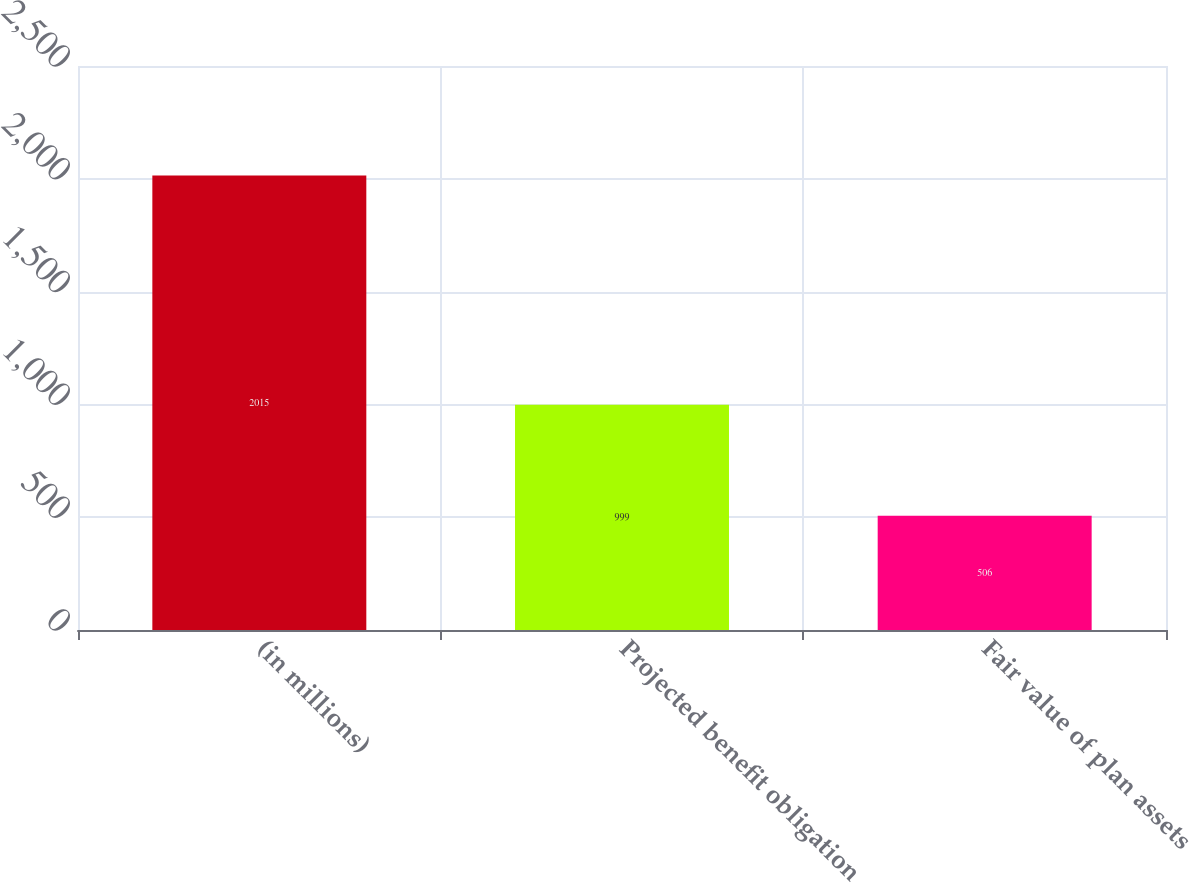Convert chart. <chart><loc_0><loc_0><loc_500><loc_500><bar_chart><fcel>(in millions)<fcel>Projected benefit obligation<fcel>Fair value of plan assets<nl><fcel>2015<fcel>999<fcel>506<nl></chart> 